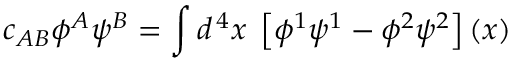Convert formula to latex. <formula><loc_0><loc_0><loc_500><loc_500>c _ { A B } \phi ^ { A } \psi ^ { B } = \int d ^ { \, 4 } x \, \left [ \phi ^ { 1 } \psi ^ { 1 } - \phi ^ { 2 } \psi ^ { 2 } \right ] \left ( x \right )</formula> 